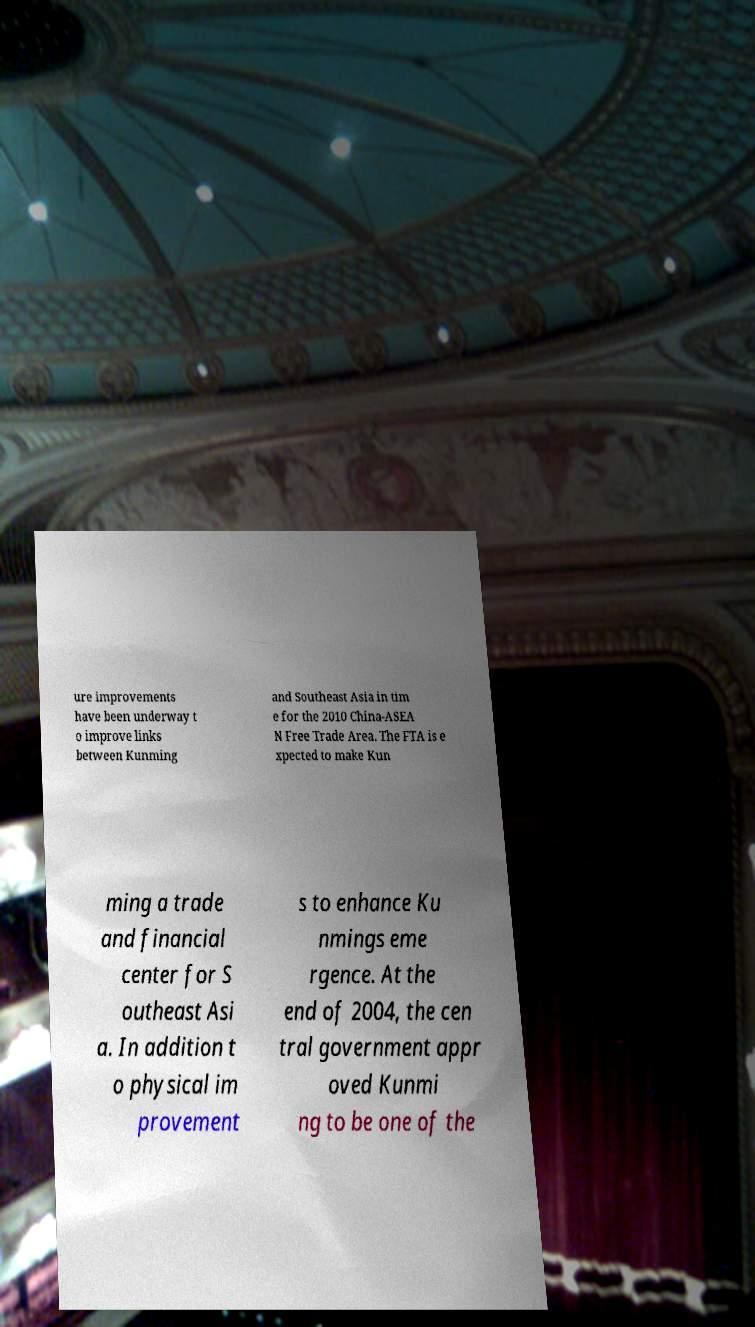Can you accurately transcribe the text from the provided image for me? ure improvements have been underway t o improve links between Kunming and Southeast Asia in tim e for the 2010 China-ASEA N Free Trade Area. The FTA is e xpected to make Kun ming a trade and financial center for S outheast Asi a. In addition t o physical im provement s to enhance Ku nmings eme rgence. At the end of 2004, the cen tral government appr oved Kunmi ng to be one of the 